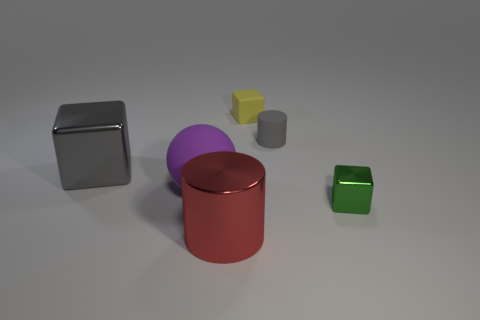What number of big gray shiny things are the same shape as the tiny green shiny object?
Your response must be concise. 1. What is the shape of the gray thing right of the cube to the left of the shiny cylinder?
Ensure brevity in your answer.  Cylinder. Do the shiny object that is in front of the green metal cube and the yellow rubber thing have the same size?
Make the answer very short. No. There is a rubber thing that is both on the left side of the small matte cylinder and behind the purple ball; what size is it?
Provide a short and direct response. Small. What number of blocks are the same size as the red cylinder?
Give a very brief answer. 1. There is a block in front of the gray shiny thing; how many red cylinders are behind it?
Offer a very short reply. 0. Do the large ball that is on the left side of the big red shiny cylinder and the big metal cylinder have the same color?
Offer a terse response. No. Are there any small gray matte cylinders on the right side of the cylinder that is behind the big metal thing behind the big ball?
Give a very brief answer. No. What is the shape of the thing that is in front of the big purple rubber object and to the left of the small metal block?
Ensure brevity in your answer.  Cylinder. Is there a metallic object of the same color as the big shiny cube?
Ensure brevity in your answer.  No. 